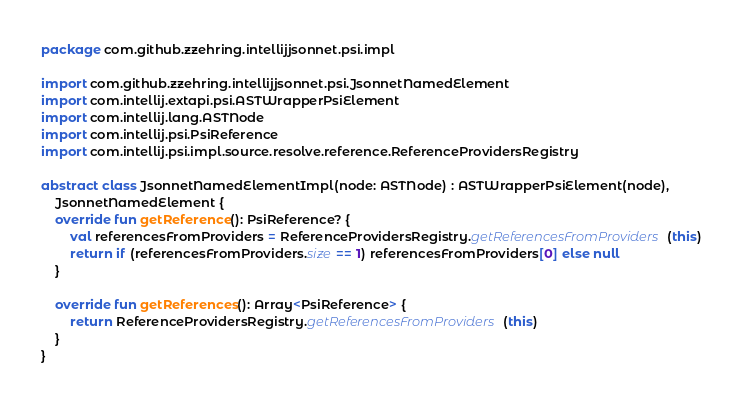Convert code to text. <code><loc_0><loc_0><loc_500><loc_500><_Kotlin_>package com.github.zzehring.intellijjsonnet.psi.impl

import com.github.zzehring.intellijjsonnet.psi.JsonnetNamedElement
import com.intellij.extapi.psi.ASTWrapperPsiElement
import com.intellij.lang.ASTNode
import com.intellij.psi.PsiReference
import com.intellij.psi.impl.source.resolve.reference.ReferenceProvidersRegistry

abstract class JsonnetNamedElementImpl(node: ASTNode) : ASTWrapperPsiElement(node),
    JsonnetNamedElement {
    override fun getReference(): PsiReference? {
        val referencesFromProviders = ReferenceProvidersRegistry.getReferencesFromProviders(this)
        return if (referencesFromProviders.size == 1) referencesFromProviders[0] else null
    }

    override fun getReferences(): Array<PsiReference> {
        return ReferenceProvidersRegistry.getReferencesFromProviders(this)
    }
}</code> 